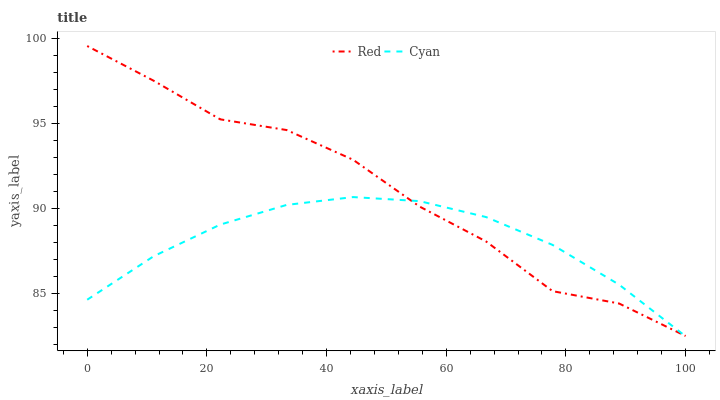Does Red have the minimum area under the curve?
Answer yes or no. No. Is Red the smoothest?
Answer yes or no. No. Does Red have the lowest value?
Answer yes or no. No. 